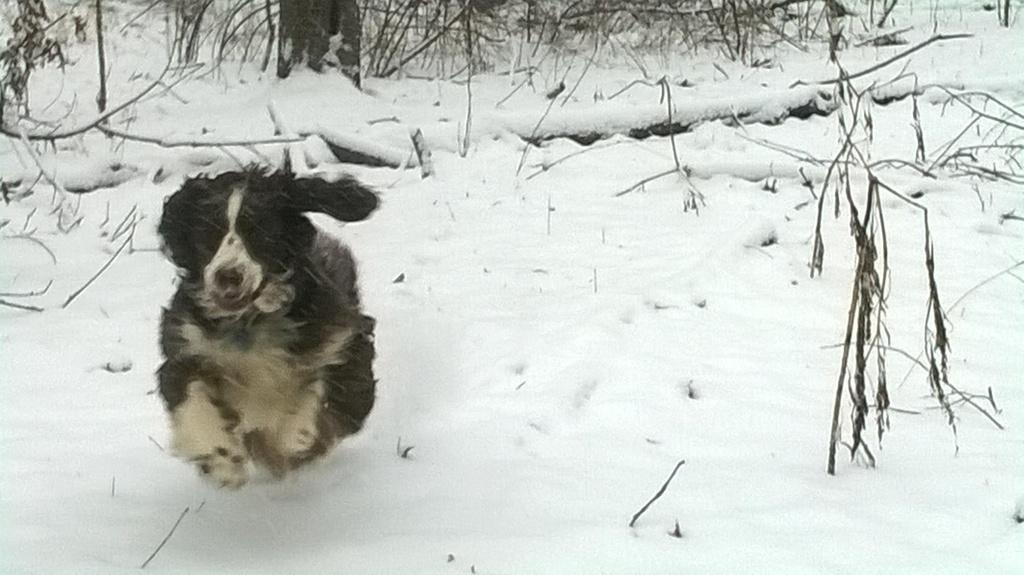In one or two sentences, can you explain what this image depicts? In this image we can see one dog running in the snow, some trees, some Stems on the snow and the surface is full of snow. 